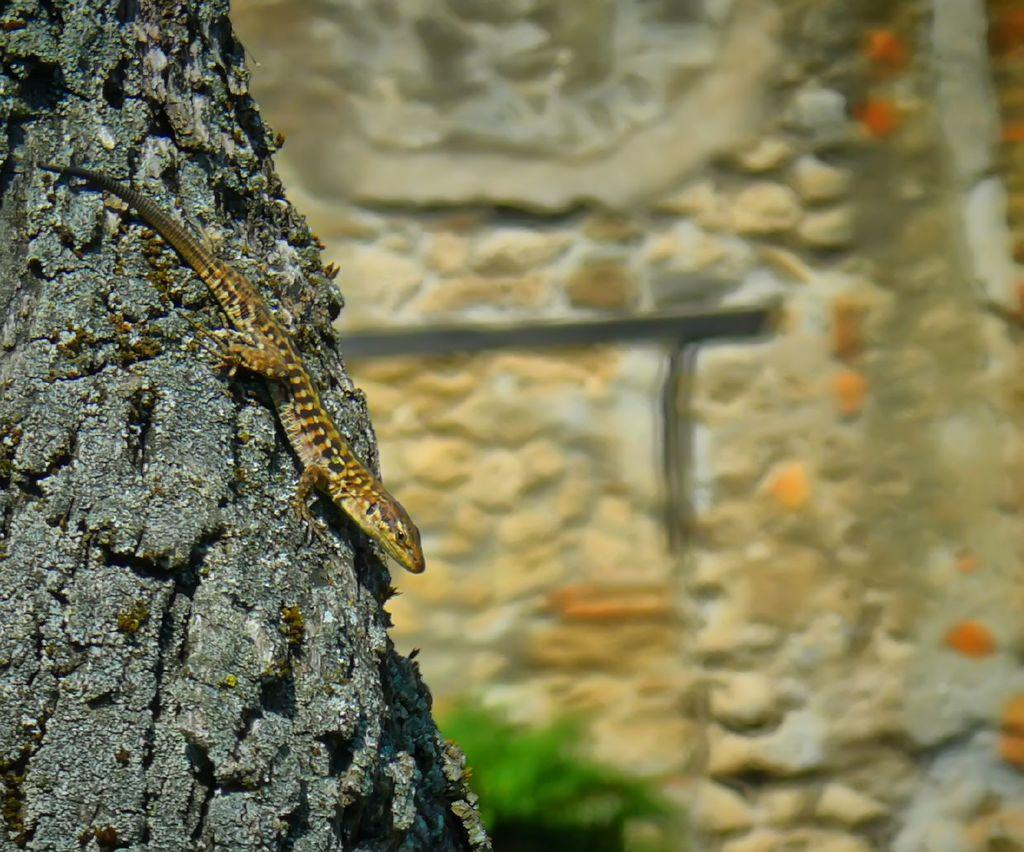What type of animal is in the image? There is a lizard in the image. Where is the lizard located? The lizard is on a tree. On which side of the tree is the lizard? The lizard is on the left side of the tree. What type of floor can be seen under the lizard in the image? There is no floor visible in the image, as the lizard is on a tree. 